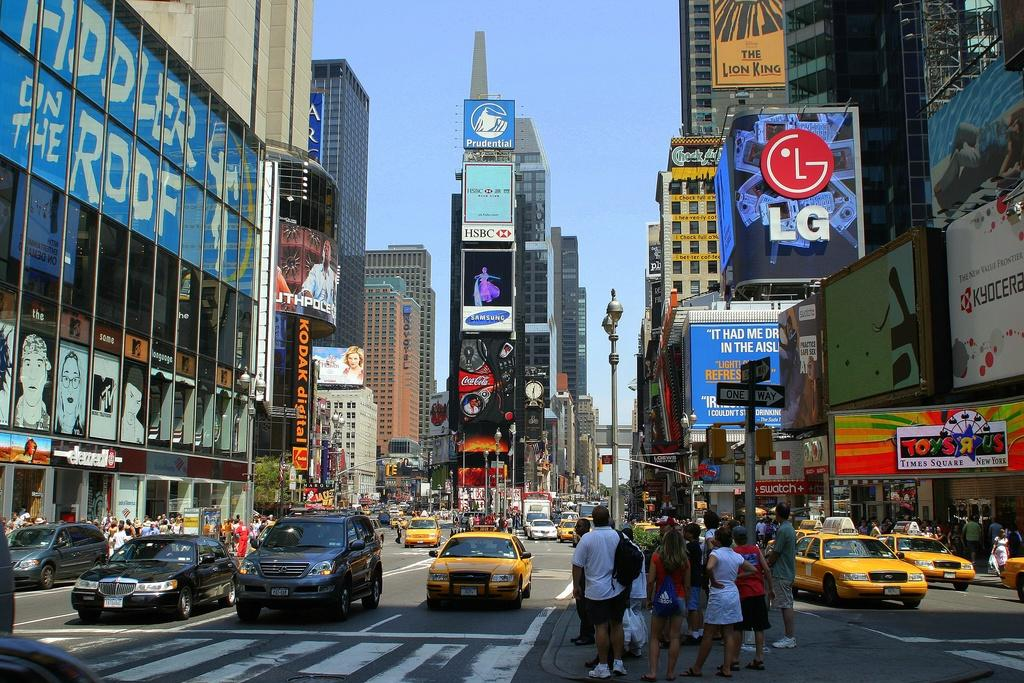<image>
Give a short and clear explanation of the subsequent image. A large blue sign is advertising the play Fiddler on the Roof  on a building right off a main, busy street. 